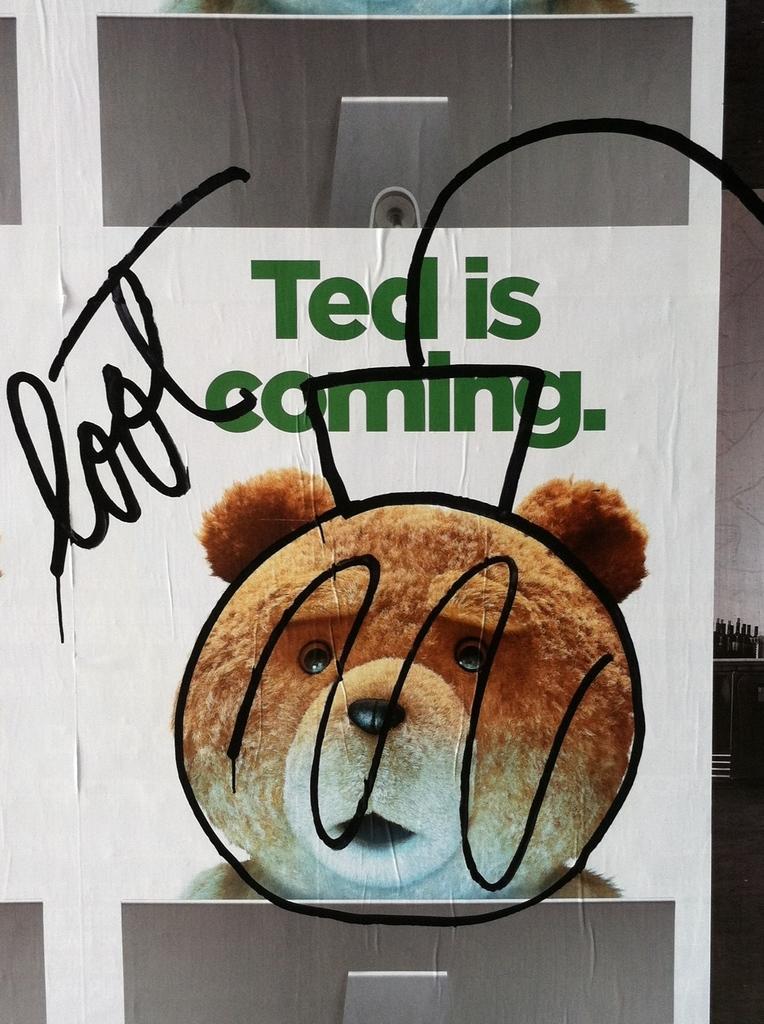In one or two sentences, can you explain what this image depicts? In this image we can see a poster. In the poster we can see an image of a teddy bear and some text. 